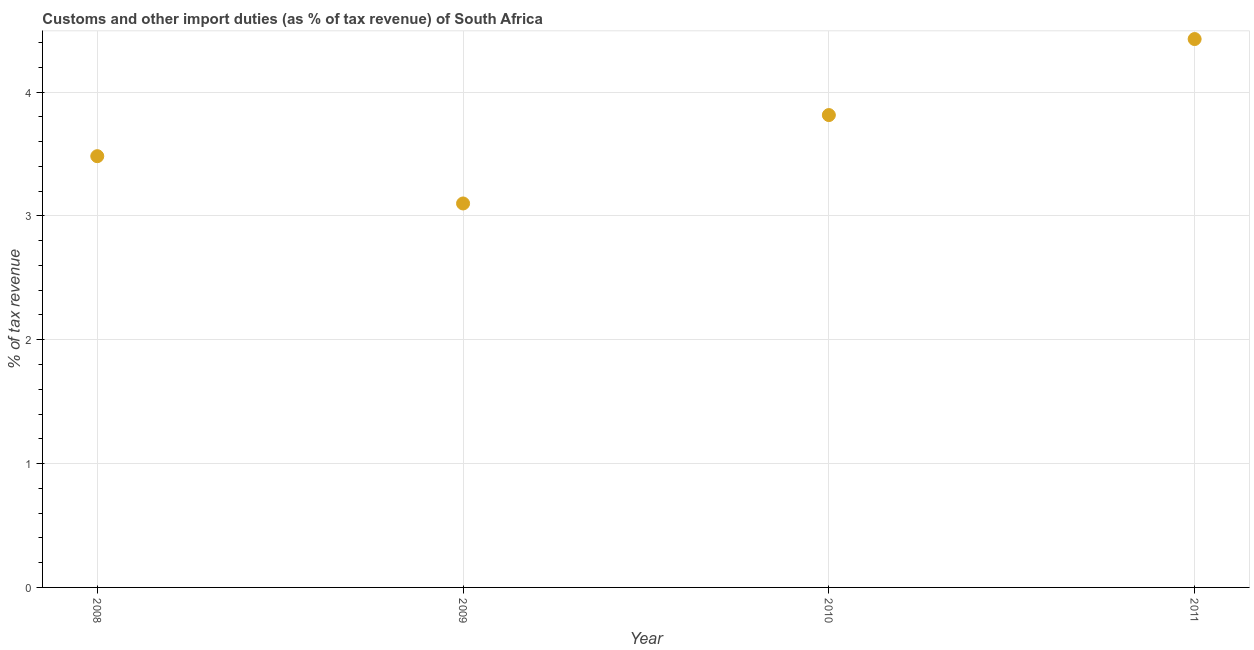What is the customs and other import duties in 2010?
Provide a short and direct response. 3.81. Across all years, what is the maximum customs and other import duties?
Provide a short and direct response. 4.43. Across all years, what is the minimum customs and other import duties?
Give a very brief answer. 3.1. In which year was the customs and other import duties maximum?
Offer a terse response. 2011. In which year was the customs and other import duties minimum?
Your response must be concise. 2009. What is the sum of the customs and other import duties?
Ensure brevity in your answer.  14.82. What is the difference between the customs and other import duties in 2009 and 2011?
Your answer should be compact. -1.33. What is the average customs and other import duties per year?
Your answer should be very brief. 3.71. What is the median customs and other import duties?
Provide a short and direct response. 3.65. Do a majority of the years between 2009 and 2010 (inclusive) have customs and other import duties greater than 1.6 %?
Your answer should be compact. Yes. What is the ratio of the customs and other import duties in 2010 to that in 2011?
Your answer should be compact. 0.86. Is the customs and other import duties in 2010 less than that in 2011?
Offer a very short reply. Yes. What is the difference between the highest and the second highest customs and other import duties?
Your answer should be very brief. 0.61. Is the sum of the customs and other import duties in 2008 and 2010 greater than the maximum customs and other import duties across all years?
Your response must be concise. Yes. What is the difference between the highest and the lowest customs and other import duties?
Ensure brevity in your answer.  1.33. Does the customs and other import duties monotonically increase over the years?
Make the answer very short. No. How many dotlines are there?
Provide a succinct answer. 1. How many years are there in the graph?
Provide a succinct answer. 4. Are the values on the major ticks of Y-axis written in scientific E-notation?
Keep it short and to the point. No. What is the title of the graph?
Your response must be concise. Customs and other import duties (as % of tax revenue) of South Africa. What is the label or title of the Y-axis?
Your answer should be very brief. % of tax revenue. What is the % of tax revenue in 2008?
Offer a very short reply. 3.48. What is the % of tax revenue in 2009?
Provide a short and direct response. 3.1. What is the % of tax revenue in 2010?
Provide a succinct answer. 3.81. What is the % of tax revenue in 2011?
Ensure brevity in your answer.  4.43. What is the difference between the % of tax revenue in 2008 and 2009?
Your response must be concise. 0.38. What is the difference between the % of tax revenue in 2008 and 2010?
Keep it short and to the point. -0.33. What is the difference between the % of tax revenue in 2008 and 2011?
Keep it short and to the point. -0.95. What is the difference between the % of tax revenue in 2009 and 2010?
Make the answer very short. -0.71. What is the difference between the % of tax revenue in 2009 and 2011?
Your answer should be compact. -1.33. What is the difference between the % of tax revenue in 2010 and 2011?
Offer a terse response. -0.61. What is the ratio of the % of tax revenue in 2008 to that in 2009?
Make the answer very short. 1.12. What is the ratio of the % of tax revenue in 2008 to that in 2010?
Your response must be concise. 0.91. What is the ratio of the % of tax revenue in 2008 to that in 2011?
Your answer should be very brief. 0.79. What is the ratio of the % of tax revenue in 2009 to that in 2010?
Make the answer very short. 0.81. What is the ratio of the % of tax revenue in 2009 to that in 2011?
Your answer should be very brief. 0.7. What is the ratio of the % of tax revenue in 2010 to that in 2011?
Your answer should be compact. 0.86. 